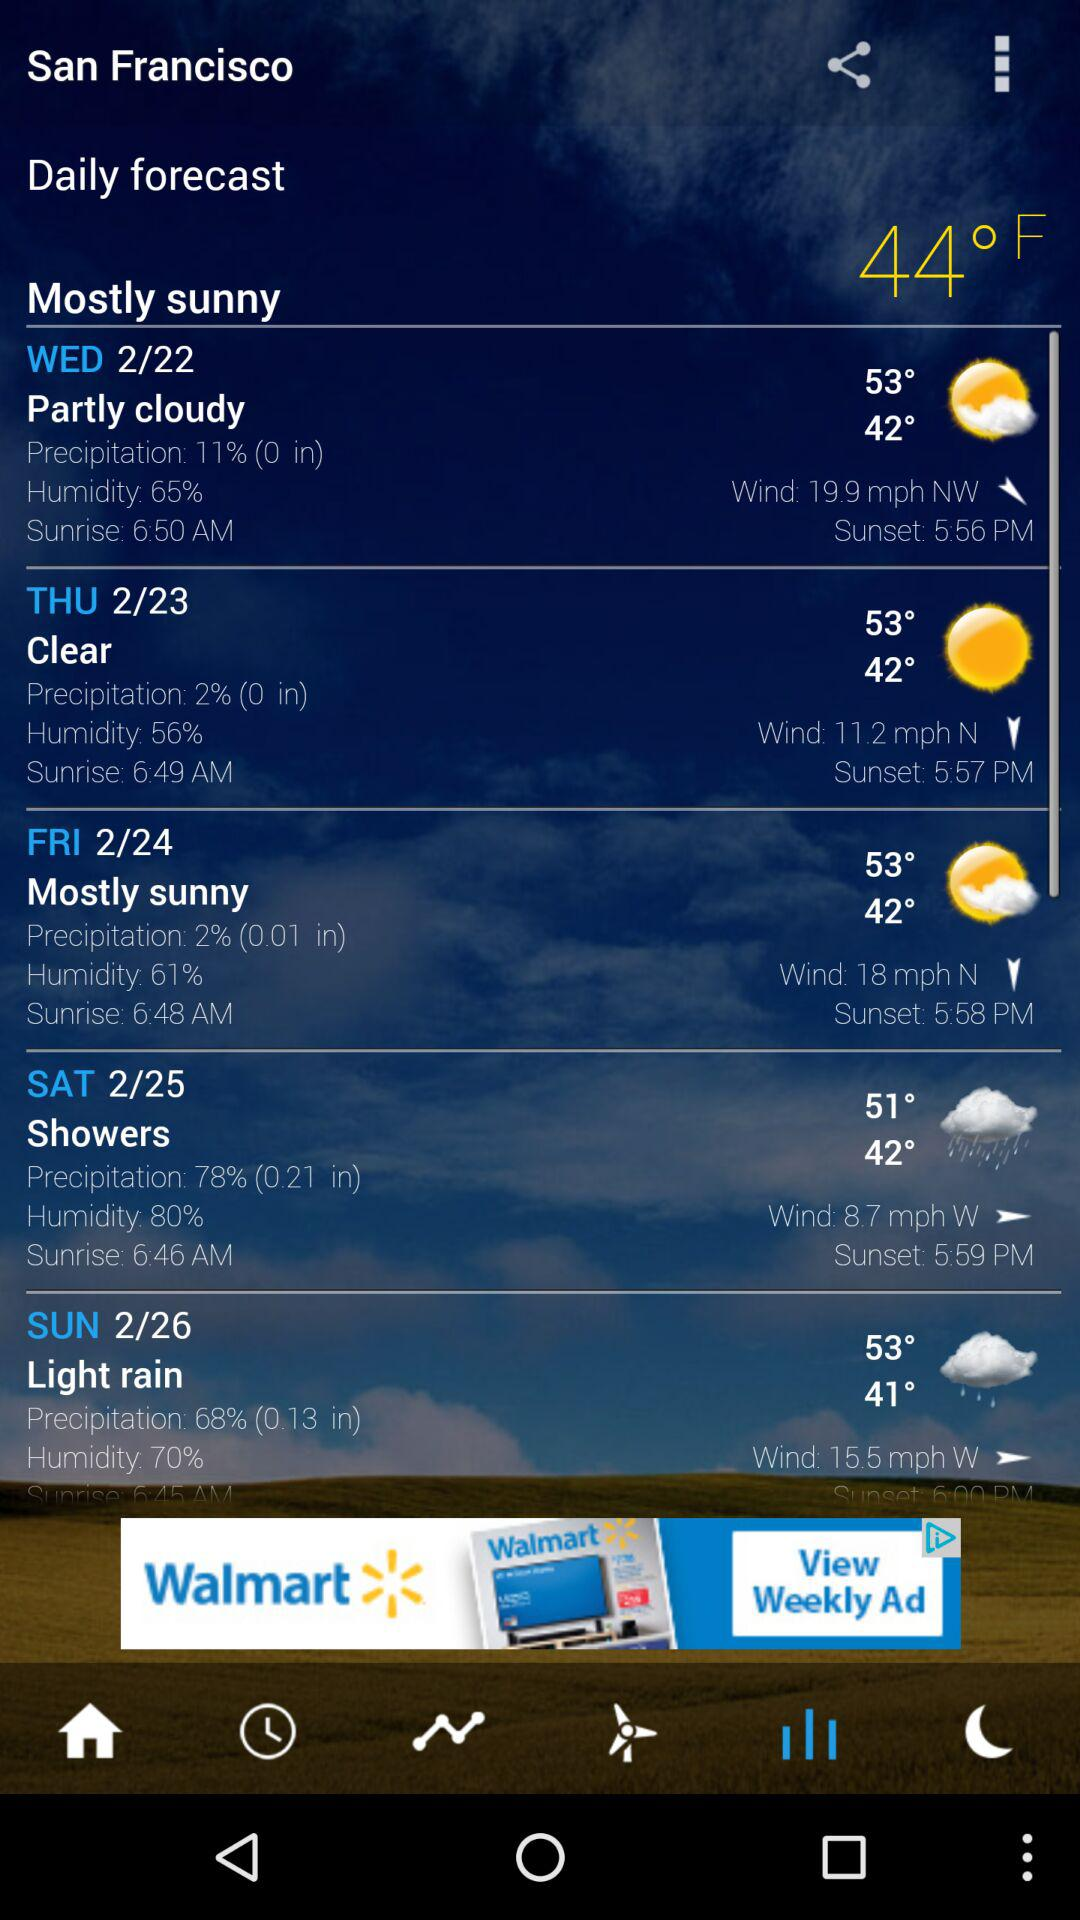What is the date on Wednesday in San Francisco? The date is February 22. 